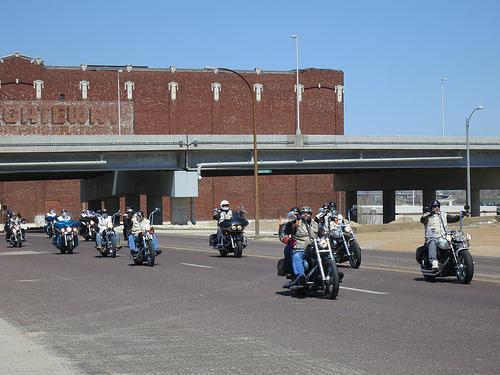How many light poles can be seen in the image?
Give a very brief answer. 5. How many white figures are painted on the top of the brick building?
Give a very brief answer. 8. 